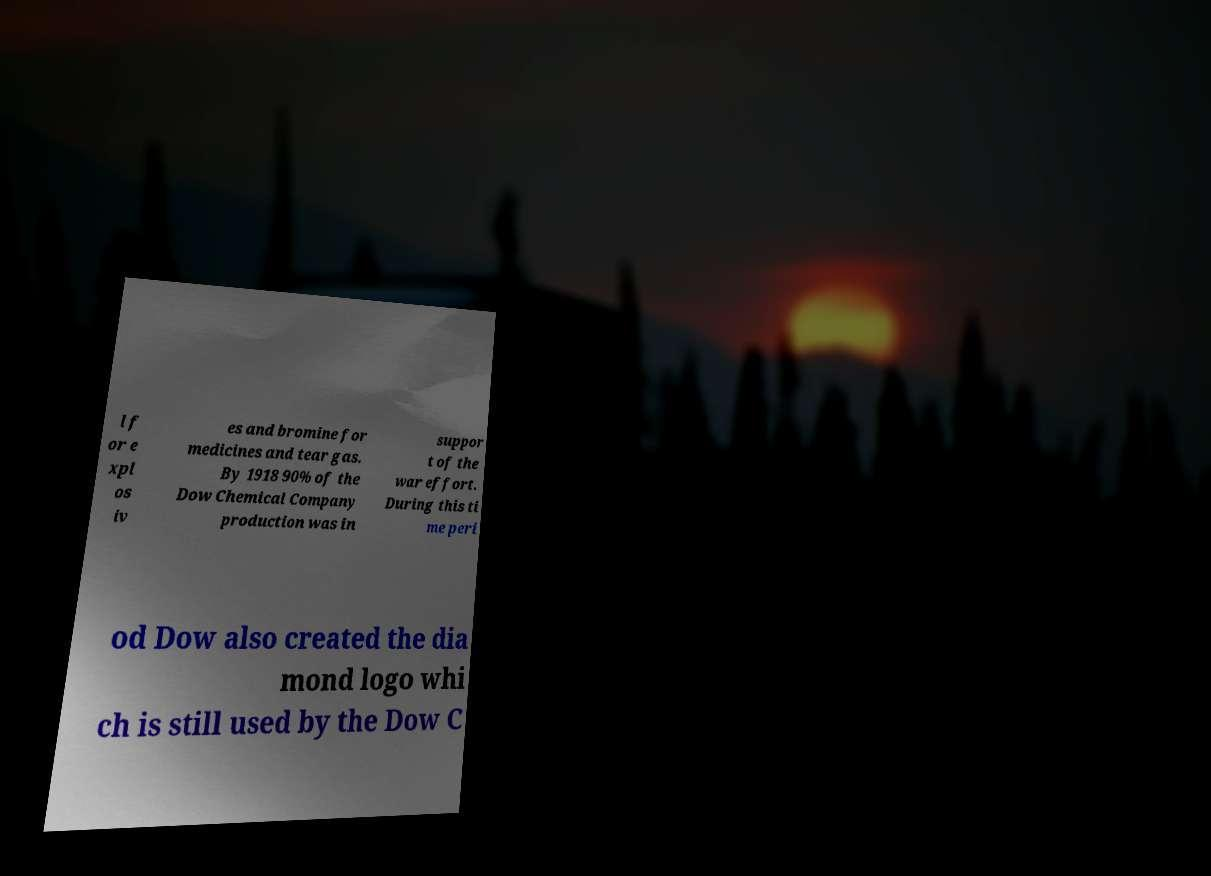What messages or text are displayed in this image? I need them in a readable, typed format. l f or e xpl os iv es and bromine for medicines and tear gas. By 1918 90% of the Dow Chemical Company production was in suppor t of the war effort. During this ti me peri od Dow also created the dia mond logo whi ch is still used by the Dow C 